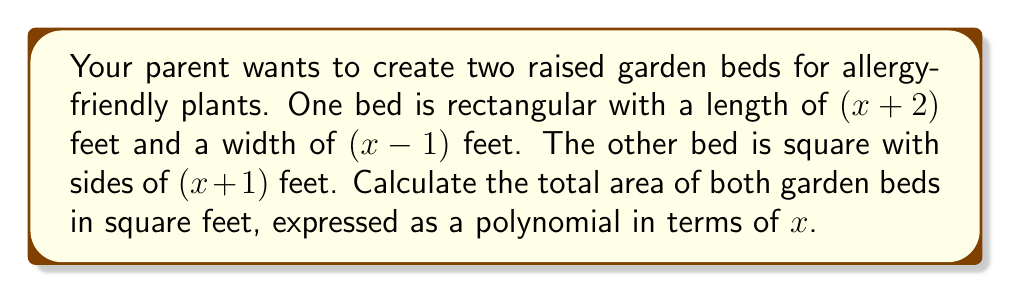Show me your answer to this math problem. Let's approach this step-by-step:

1) For the rectangular bed:
   - Length = $(x+2)$ feet
   - Width = $(x-1)$ feet
   - Area of rectangle = length × width
   $$A_1 = (x+2)(x-1)$$

2) Expand the expression for $A_1$:
   $$(x+2)(x-1) = x^2 - x + 2x - 2 = x^2 + x - 2$$

3) For the square bed:
   - Side length = $(x+1)$ feet
   - Area of square = side length squared
   $$A_2 = (x+1)^2$$

4) Expand the expression for $A_2$:
   $$(x+1)^2 = x^2 + 2x + 1$$

5) Total area is the sum of both areas:
   $$A_{total} = A_1 + A_2$$
   $$A_{total} = (x^2 + x - 2) + (x^2 + 2x + 1)$$

6) Combine like terms:
   $$A_{total} = x^2 + x - 2 + x^2 + 2x + 1$$
   $$A_{total} = 2x^2 + 3x - 1$$

Therefore, the total area of both garden beds is $2x^2 + 3x - 1$ square feet.
Answer: $2x^2 + 3x - 1$ sq ft 